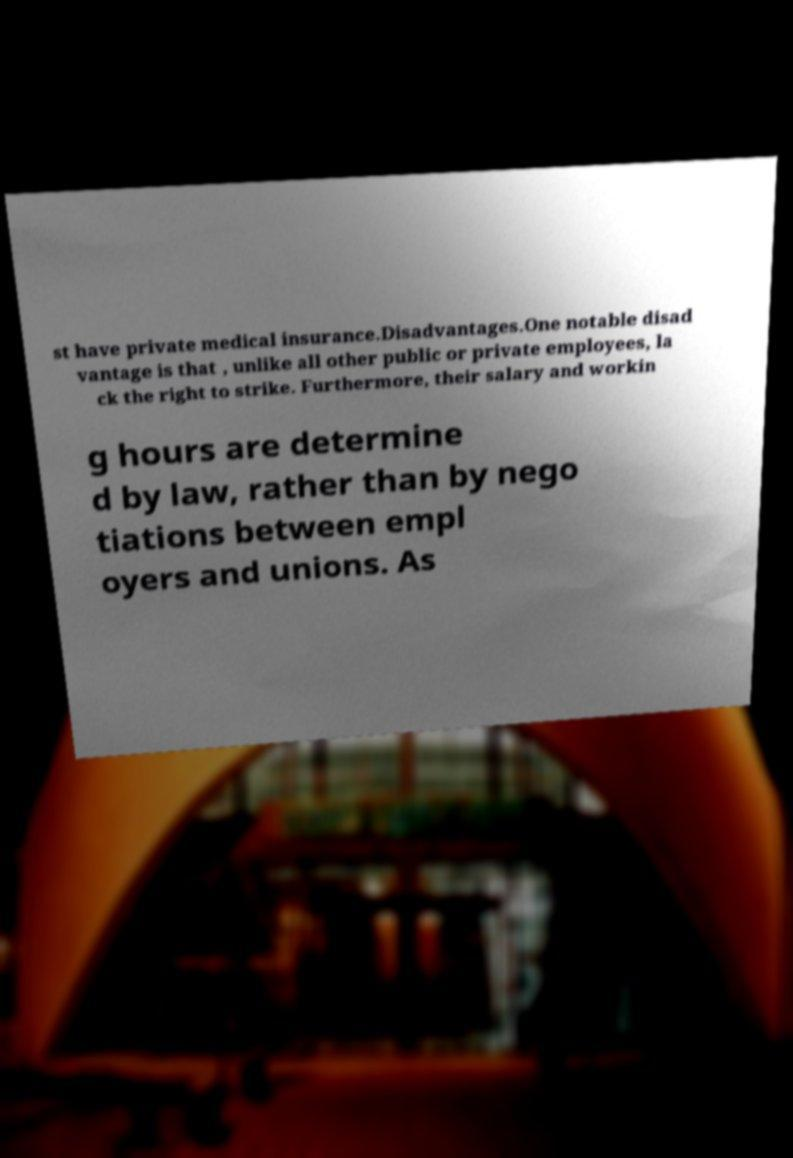There's text embedded in this image that I need extracted. Can you transcribe it verbatim? st have private medical insurance.Disadvantages.One notable disad vantage is that , unlike all other public or private employees, la ck the right to strike. Furthermore, their salary and workin g hours are determine d by law, rather than by nego tiations between empl oyers and unions. As 